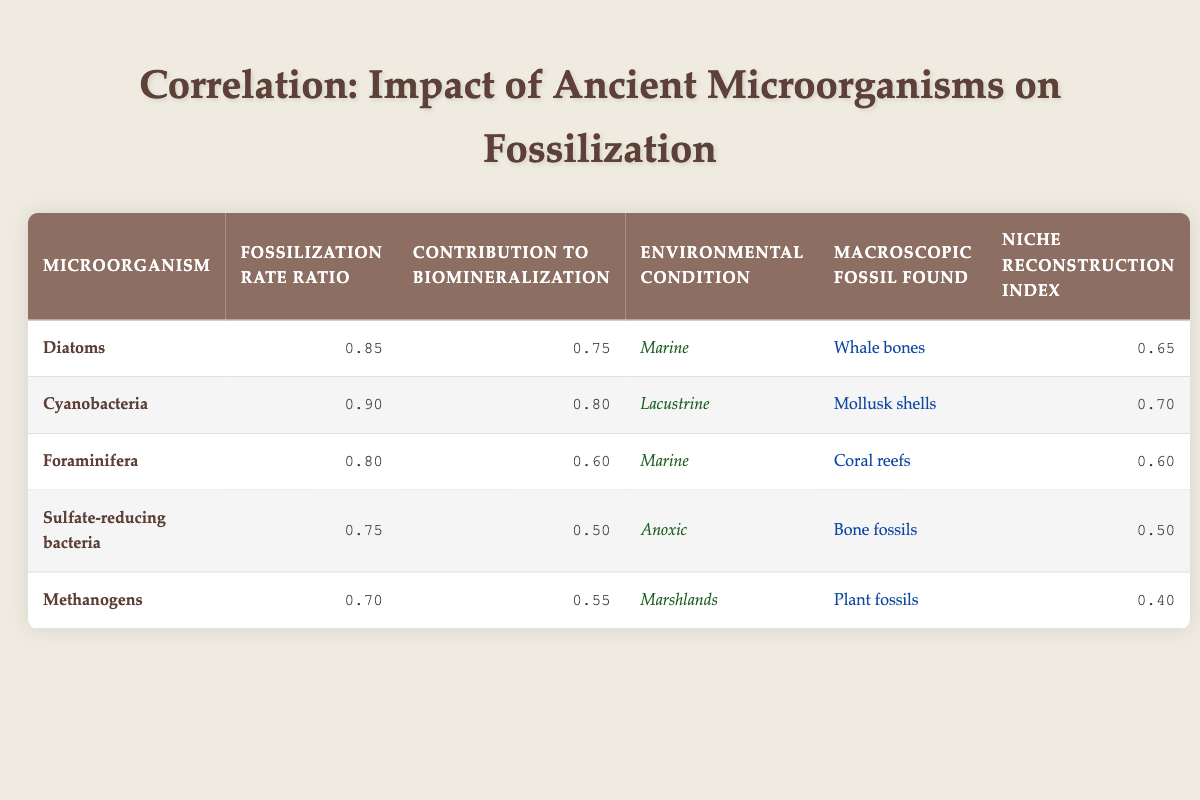What is the fossilization rate ratio for Diatoms? Looking at the table, the fossilization rate ratio for Diatoms is listed in the second column of the row corresponding to Diatoms. The value is 0.85.
Answer: 0.85 What environmental condition is associated with Cyanobacteria? The table shows that Cyanobacteria is listed with the environmental condition in its corresponding row. It states the condition is lacustrine.
Answer: Lacustrine Which microorganism has the highest contribution to biomineralization? To find the microorganism with the highest contribution to biomineralization, I need to compare the values in the corresponding column. The values for the respective microorganisms are 0.75, 0.80, 0.60, 0.50, and 0.55. The highest value is 0.80 for Cyanobacteria.
Answer: Cyanobacteria What is the average fossilization rate ratio of all microorganisms? I will sum up the fossilization rate ratios from all microorganisms: 0.85 + 0.90 + 0.80 + 0.75 + 0.70 = 4.00. To find the average, I then divide by the number of microorganisms, which is 5. Therefore, the average is 4.00 / 5 = 0.80.
Answer: 0.80 Is it true that Methanogens have the highest niche reconstruction index? To determine this, I will look at the niche reconstruction index for each microorganism. The values are 0.65, 0.70, 0.60, 0.50, and 0.40. The highest value is 0.70 for Cyanobacteria, thus Methanogens do not have the highest index.
Answer: No Which fossil found is associated with sulfate-reducing bacteria? I will refer to the table to check which macroscopic fossil coexists with sulfate-reducing bacteria. According to the table, the fossil found for sulfate-reducing bacteria is bone fossils.
Answer: Bone fossils What is the contribution to biomineralization for Foraminifera? To answer this question, I simply need to look at the row for Foraminifera and find the contribution to biomineralization. That value is 0.60.
Answer: 0.60 How many microorganisms are found in marine environments? Referring to the table, I need to check the environmental condition for each microorganism. Diatoms and Foraminifera are both listed under marine conditions which makes it a total of 2 microorganisms.
Answer: 2 Compare the fossilization rate ratio of Methanogens to that of Foraminifera. Methanogens have a fossilization rate ratio of 0.70 and Foraminifera have a ratio of 0.80. The comparison shows that Foraminifera have a higher fossilization rate ratio than Methanogens by 0.10 (0.80 - 0.70).
Answer: Foraminifera is higher by 0.10 